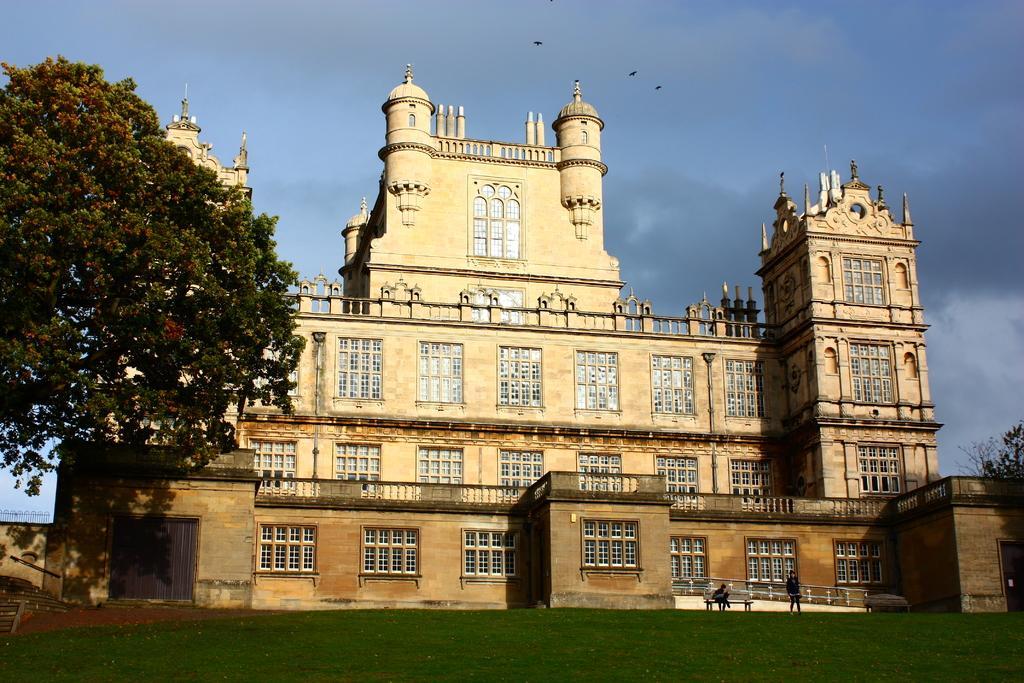Could you give a brief overview of what you see in this image? In this image, we can see a building, at the left side there is a tree, we can see green grass on the ground, at the top there is a blue color sky. 